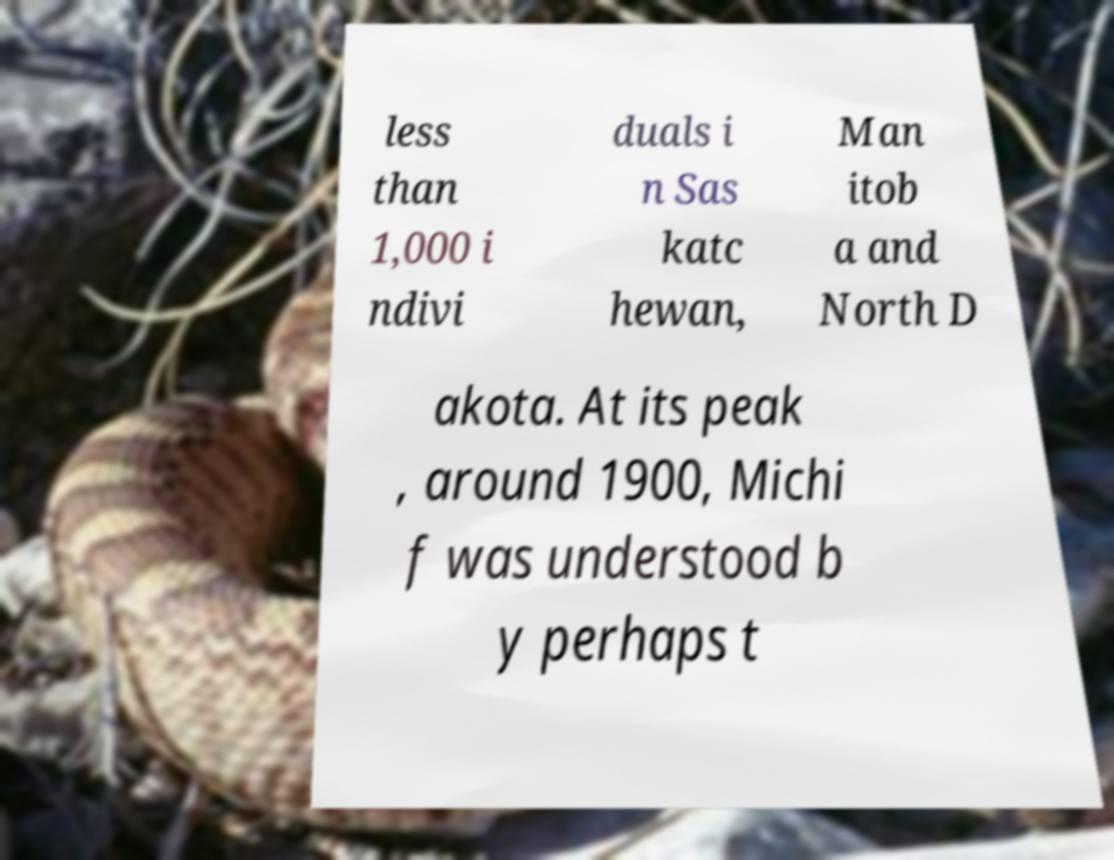There's text embedded in this image that I need extracted. Can you transcribe it verbatim? less than 1,000 i ndivi duals i n Sas katc hewan, Man itob a and North D akota. At its peak , around 1900, Michi f was understood b y perhaps t 